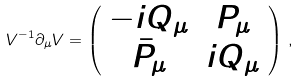Convert formula to latex. <formula><loc_0><loc_0><loc_500><loc_500>V ^ { - 1 } \partial _ { \mu } V = \left ( \begin{array} { c c } - i Q _ { \mu } & P _ { \mu } \\ \bar { P } _ { \mu } & i Q _ { \mu } \end{array} \right ) \, ,</formula> 